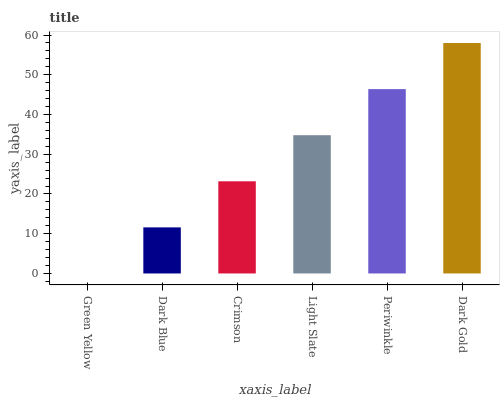Is Green Yellow the minimum?
Answer yes or no. Yes. Is Dark Gold the maximum?
Answer yes or no. Yes. Is Dark Blue the minimum?
Answer yes or no. No. Is Dark Blue the maximum?
Answer yes or no. No. Is Dark Blue greater than Green Yellow?
Answer yes or no. Yes. Is Green Yellow less than Dark Blue?
Answer yes or no. Yes. Is Green Yellow greater than Dark Blue?
Answer yes or no. No. Is Dark Blue less than Green Yellow?
Answer yes or no. No. Is Light Slate the high median?
Answer yes or no. Yes. Is Crimson the low median?
Answer yes or no. Yes. Is Dark Gold the high median?
Answer yes or no. No. Is Green Yellow the low median?
Answer yes or no. No. 